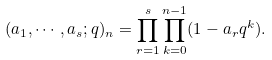Convert formula to latex. <formula><loc_0><loc_0><loc_500><loc_500>( a _ { 1 } , \cdots , a _ { s } ; q ) _ { n } = \prod _ { r = 1 } ^ { s } \prod _ { k = 0 } ^ { n - 1 } ( 1 - a _ { r } q ^ { k } ) .</formula> 